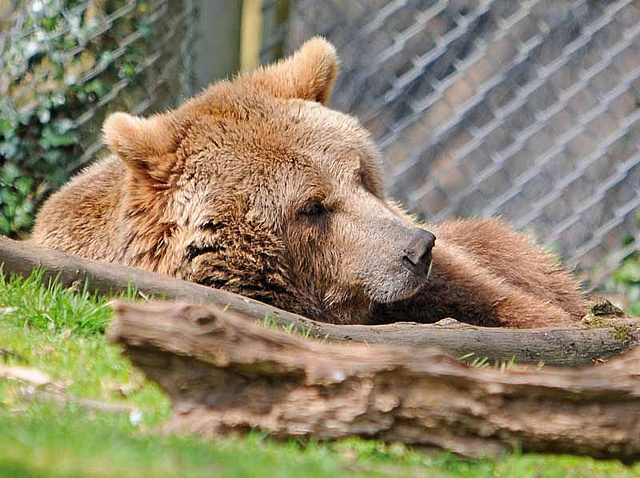Describe the objects in this image and their specific colors. I can see a bear in tan and gray tones in this image. 